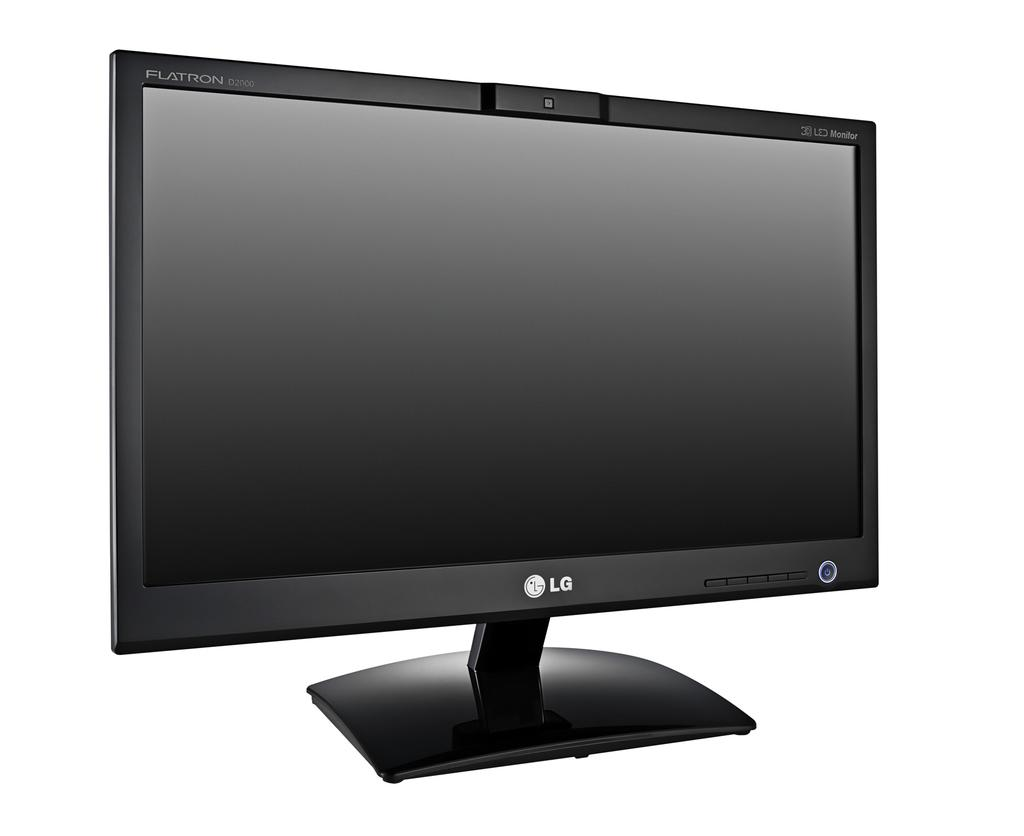<image>
Offer a succinct explanation of the picture presented. Black LG monitor that is turned off in a picture 